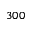<formula> <loc_0><loc_0><loc_500><loc_500>3 0 0</formula> 